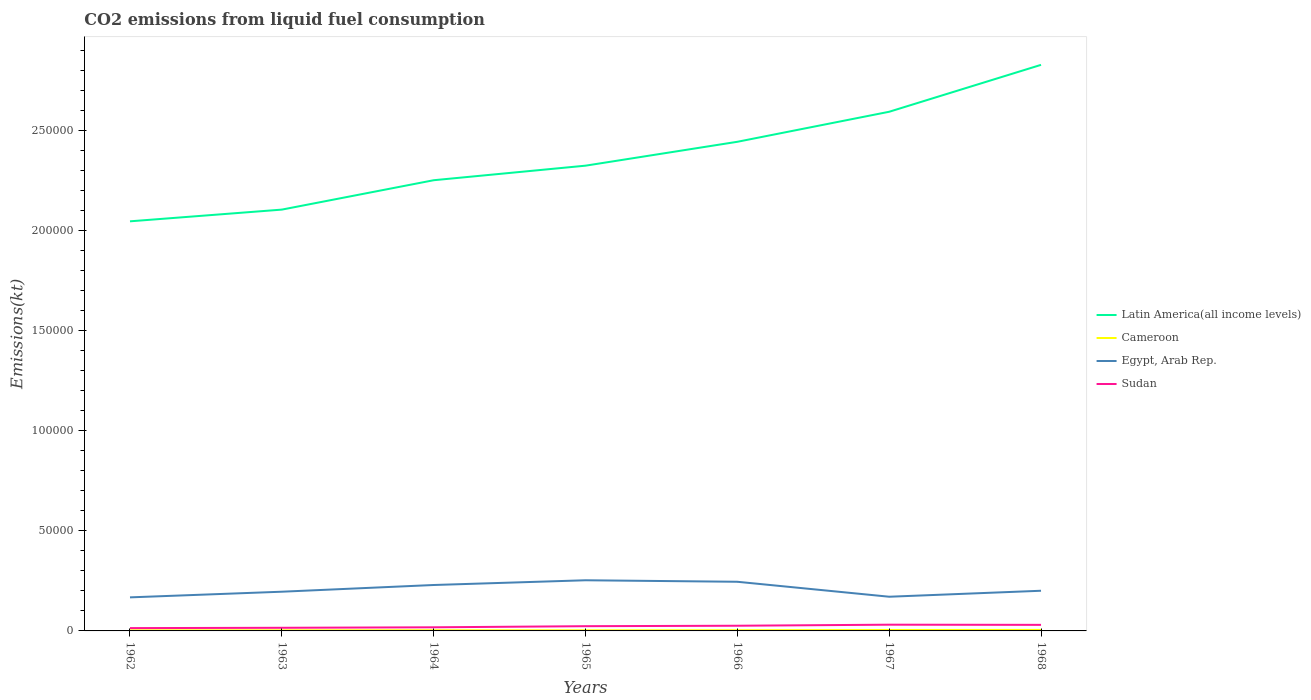How many different coloured lines are there?
Make the answer very short. 4. Is the number of lines equal to the number of legend labels?
Make the answer very short. Yes. Across all years, what is the maximum amount of CO2 emitted in Cameroon?
Provide a succinct answer. 289.69. In which year was the amount of CO2 emitted in Latin America(all income levels) maximum?
Your response must be concise. 1962. What is the total amount of CO2 emitted in Egypt, Arab Rep. in the graph?
Give a very brief answer. 751.74. What is the difference between the highest and the second highest amount of CO2 emitted in Latin America(all income levels)?
Keep it short and to the point. 7.82e+04. Is the amount of CO2 emitted in Egypt, Arab Rep. strictly greater than the amount of CO2 emitted in Cameroon over the years?
Provide a succinct answer. No. How many years are there in the graph?
Make the answer very short. 7. What is the difference between two consecutive major ticks on the Y-axis?
Offer a terse response. 5.00e+04. How many legend labels are there?
Ensure brevity in your answer.  4. What is the title of the graph?
Keep it short and to the point. CO2 emissions from liquid fuel consumption. What is the label or title of the Y-axis?
Your answer should be compact. Emissions(kt). What is the Emissions(kt) of Latin America(all income levels) in 1962?
Your response must be concise. 2.05e+05. What is the Emissions(kt) of Cameroon in 1962?
Give a very brief answer. 289.69. What is the Emissions(kt) of Egypt, Arab Rep. in 1962?
Ensure brevity in your answer.  1.68e+04. What is the Emissions(kt) in Sudan in 1962?
Ensure brevity in your answer.  1408.13. What is the Emissions(kt) in Latin America(all income levels) in 1963?
Make the answer very short. 2.11e+05. What is the Emissions(kt) of Cameroon in 1963?
Provide a succinct answer. 300.69. What is the Emissions(kt) of Egypt, Arab Rep. in 1963?
Ensure brevity in your answer.  1.96e+04. What is the Emissions(kt) of Sudan in 1963?
Keep it short and to the point. 1569.48. What is the Emissions(kt) of Latin America(all income levels) in 1964?
Offer a terse response. 2.25e+05. What is the Emissions(kt) of Cameroon in 1964?
Your answer should be very brief. 337.36. What is the Emissions(kt) of Egypt, Arab Rep. in 1964?
Offer a very short reply. 2.30e+04. What is the Emissions(kt) of Sudan in 1964?
Ensure brevity in your answer.  1815.16. What is the Emissions(kt) of Latin America(all income levels) in 1965?
Keep it short and to the point. 2.33e+05. What is the Emissions(kt) of Cameroon in 1965?
Keep it short and to the point. 311.69. What is the Emissions(kt) of Egypt, Arab Rep. in 1965?
Your response must be concise. 2.53e+04. What is the Emissions(kt) of Sudan in 1965?
Offer a very short reply. 2368.88. What is the Emissions(kt) in Latin America(all income levels) in 1966?
Offer a very short reply. 2.44e+05. What is the Emissions(kt) in Cameroon in 1966?
Give a very brief answer. 344.7. What is the Emissions(kt) of Egypt, Arab Rep. in 1966?
Provide a succinct answer. 2.46e+04. What is the Emissions(kt) in Sudan in 1966?
Make the answer very short. 2592.57. What is the Emissions(kt) in Latin America(all income levels) in 1967?
Offer a terse response. 2.59e+05. What is the Emissions(kt) in Cameroon in 1967?
Provide a succinct answer. 458.38. What is the Emissions(kt) of Egypt, Arab Rep. in 1967?
Offer a very short reply. 1.71e+04. What is the Emissions(kt) of Sudan in 1967?
Offer a terse response. 3116.95. What is the Emissions(kt) in Latin America(all income levels) in 1968?
Ensure brevity in your answer.  2.83e+05. What is the Emissions(kt) in Cameroon in 1968?
Offer a very short reply. 502.38. What is the Emissions(kt) in Egypt, Arab Rep. in 1968?
Provide a short and direct response. 2.01e+04. What is the Emissions(kt) in Sudan in 1968?
Provide a succinct answer. 3028.94. Across all years, what is the maximum Emissions(kt) of Latin America(all income levels)?
Give a very brief answer. 2.83e+05. Across all years, what is the maximum Emissions(kt) in Cameroon?
Make the answer very short. 502.38. Across all years, what is the maximum Emissions(kt) in Egypt, Arab Rep.?
Your response must be concise. 2.53e+04. Across all years, what is the maximum Emissions(kt) in Sudan?
Your answer should be very brief. 3116.95. Across all years, what is the minimum Emissions(kt) in Latin America(all income levels)?
Offer a very short reply. 2.05e+05. Across all years, what is the minimum Emissions(kt) of Cameroon?
Offer a very short reply. 289.69. Across all years, what is the minimum Emissions(kt) of Egypt, Arab Rep.?
Keep it short and to the point. 1.68e+04. Across all years, what is the minimum Emissions(kt) in Sudan?
Your response must be concise. 1408.13. What is the total Emissions(kt) in Latin America(all income levels) in the graph?
Offer a terse response. 1.66e+06. What is the total Emissions(kt) in Cameroon in the graph?
Offer a terse response. 2544.9. What is the total Emissions(kt) in Egypt, Arab Rep. in the graph?
Your response must be concise. 1.46e+05. What is the total Emissions(kt) in Sudan in the graph?
Offer a very short reply. 1.59e+04. What is the difference between the Emissions(kt) in Latin America(all income levels) in 1962 and that in 1963?
Provide a short and direct response. -5855.18. What is the difference between the Emissions(kt) in Cameroon in 1962 and that in 1963?
Make the answer very short. -11. What is the difference between the Emissions(kt) in Egypt, Arab Rep. in 1962 and that in 1963?
Your answer should be compact. -2823.59. What is the difference between the Emissions(kt) in Sudan in 1962 and that in 1963?
Your answer should be very brief. -161.35. What is the difference between the Emissions(kt) in Latin America(all income levels) in 1962 and that in 1964?
Your answer should be very brief. -2.05e+04. What is the difference between the Emissions(kt) in Cameroon in 1962 and that in 1964?
Ensure brevity in your answer.  -47.67. What is the difference between the Emissions(kt) of Egypt, Arab Rep. in 1962 and that in 1964?
Give a very brief answer. -6178.9. What is the difference between the Emissions(kt) of Sudan in 1962 and that in 1964?
Offer a very short reply. -407.04. What is the difference between the Emissions(kt) in Latin America(all income levels) in 1962 and that in 1965?
Your response must be concise. -2.78e+04. What is the difference between the Emissions(kt) of Cameroon in 1962 and that in 1965?
Offer a very short reply. -22. What is the difference between the Emissions(kt) in Egypt, Arab Rep. in 1962 and that in 1965?
Your response must be concise. -8544.11. What is the difference between the Emissions(kt) of Sudan in 1962 and that in 1965?
Offer a very short reply. -960.75. What is the difference between the Emissions(kt) of Latin America(all income levels) in 1962 and that in 1966?
Keep it short and to the point. -3.97e+04. What is the difference between the Emissions(kt) in Cameroon in 1962 and that in 1966?
Your answer should be compact. -55.01. What is the difference between the Emissions(kt) in Egypt, Arab Rep. in 1962 and that in 1966?
Make the answer very short. -7792.38. What is the difference between the Emissions(kt) in Sudan in 1962 and that in 1966?
Your answer should be compact. -1184.44. What is the difference between the Emissions(kt) in Latin America(all income levels) in 1962 and that in 1967?
Provide a short and direct response. -5.48e+04. What is the difference between the Emissions(kt) of Cameroon in 1962 and that in 1967?
Your answer should be compact. -168.68. What is the difference between the Emissions(kt) in Egypt, Arab Rep. in 1962 and that in 1967?
Your response must be concise. -315.36. What is the difference between the Emissions(kt) in Sudan in 1962 and that in 1967?
Your answer should be very brief. -1708.82. What is the difference between the Emissions(kt) of Latin America(all income levels) in 1962 and that in 1968?
Ensure brevity in your answer.  -7.82e+04. What is the difference between the Emissions(kt) in Cameroon in 1962 and that in 1968?
Make the answer very short. -212.69. What is the difference between the Emissions(kt) in Egypt, Arab Rep. in 1962 and that in 1968?
Provide a succinct answer. -3300.3. What is the difference between the Emissions(kt) of Sudan in 1962 and that in 1968?
Give a very brief answer. -1620.81. What is the difference between the Emissions(kt) in Latin America(all income levels) in 1963 and that in 1964?
Your response must be concise. -1.47e+04. What is the difference between the Emissions(kt) of Cameroon in 1963 and that in 1964?
Make the answer very short. -36.67. What is the difference between the Emissions(kt) of Egypt, Arab Rep. in 1963 and that in 1964?
Provide a succinct answer. -3355.3. What is the difference between the Emissions(kt) in Sudan in 1963 and that in 1964?
Give a very brief answer. -245.69. What is the difference between the Emissions(kt) in Latin America(all income levels) in 1963 and that in 1965?
Keep it short and to the point. -2.20e+04. What is the difference between the Emissions(kt) of Cameroon in 1963 and that in 1965?
Make the answer very short. -11. What is the difference between the Emissions(kt) of Egypt, Arab Rep. in 1963 and that in 1965?
Provide a short and direct response. -5720.52. What is the difference between the Emissions(kt) in Sudan in 1963 and that in 1965?
Provide a succinct answer. -799.41. What is the difference between the Emissions(kt) of Latin America(all income levels) in 1963 and that in 1966?
Keep it short and to the point. -3.39e+04. What is the difference between the Emissions(kt) in Cameroon in 1963 and that in 1966?
Make the answer very short. -44. What is the difference between the Emissions(kt) in Egypt, Arab Rep. in 1963 and that in 1966?
Your response must be concise. -4968.78. What is the difference between the Emissions(kt) of Sudan in 1963 and that in 1966?
Your response must be concise. -1023.09. What is the difference between the Emissions(kt) in Latin America(all income levels) in 1963 and that in 1967?
Provide a succinct answer. -4.89e+04. What is the difference between the Emissions(kt) of Cameroon in 1963 and that in 1967?
Your answer should be very brief. -157.68. What is the difference between the Emissions(kt) of Egypt, Arab Rep. in 1963 and that in 1967?
Your answer should be compact. 2508.23. What is the difference between the Emissions(kt) in Sudan in 1963 and that in 1967?
Provide a short and direct response. -1547.47. What is the difference between the Emissions(kt) in Latin America(all income levels) in 1963 and that in 1968?
Offer a very short reply. -7.23e+04. What is the difference between the Emissions(kt) in Cameroon in 1963 and that in 1968?
Give a very brief answer. -201.69. What is the difference between the Emissions(kt) of Egypt, Arab Rep. in 1963 and that in 1968?
Provide a short and direct response. -476.71. What is the difference between the Emissions(kt) in Sudan in 1963 and that in 1968?
Provide a succinct answer. -1459.47. What is the difference between the Emissions(kt) in Latin America(all income levels) in 1964 and that in 1965?
Your answer should be compact. -7274.5. What is the difference between the Emissions(kt) in Cameroon in 1964 and that in 1965?
Give a very brief answer. 25.67. What is the difference between the Emissions(kt) in Egypt, Arab Rep. in 1964 and that in 1965?
Ensure brevity in your answer.  -2365.22. What is the difference between the Emissions(kt) of Sudan in 1964 and that in 1965?
Make the answer very short. -553.72. What is the difference between the Emissions(kt) of Latin America(all income levels) in 1964 and that in 1966?
Offer a terse response. -1.92e+04. What is the difference between the Emissions(kt) in Cameroon in 1964 and that in 1966?
Keep it short and to the point. -7.33. What is the difference between the Emissions(kt) of Egypt, Arab Rep. in 1964 and that in 1966?
Give a very brief answer. -1613.48. What is the difference between the Emissions(kt) of Sudan in 1964 and that in 1966?
Provide a succinct answer. -777.4. What is the difference between the Emissions(kt) in Latin America(all income levels) in 1964 and that in 1967?
Provide a short and direct response. -3.42e+04. What is the difference between the Emissions(kt) in Cameroon in 1964 and that in 1967?
Keep it short and to the point. -121.01. What is the difference between the Emissions(kt) of Egypt, Arab Rep. in 1964 and that in 1967?
Offer a terse response. 5863.53. What is the difference between the Emissions(kt) in Sudan in 1964 and that in 1967?
Provide a short and direct response. -1301.79. What is the difference between the Emissions(kt) of Latin America(all income levels) in 1964 and that in 1968?
Make the answer very short. -5.77e+04. What is the difference between the Emissions(kt) in Cameroon in 1964 and that in 1968?
Your answer should be compact. -165.01. What is the difference between the Emissions(kt) of Egypt, Arab Rep. in 1964 and that in 1968?
Make the answer very short. 2878.59. What is the difference between the Emissions(kt) in Sudan in 1964 and that in 1968?
Provide a short and direct response. -1213.78. What is the difference between the Emissions(kt) in Latin America(all income levels) in 1965 and that in 1966?
Provide a succinct answer. -1.19e+04. What is the difference between the Emissions(kt) in Cameroon in 1965 and that in 1966?
Provide a succinct answer. -33. What is the difference between the Emissions(kt) of Egypt, Arab Rep. in 1965 and that in 1966?
Offer a very short reply. 751.74. What is the difference between the Emissions(kt) of Sudan in 1965 and that in 1966?
Make the answer very short. -223.69. What is the difference between the Emissions(kt) in Latin America(all income levels) in 1965 and that in 1967?
Your answer should be compact. -2.69e+04. What is the difference between the Emissions(kt) in Cameroon in 1965 and that in 1967?
Make the answer very short. -146.68. What is the difference between the Emissions(kt) of Egypt, Arab Rep. in 1965 and that in 1967?
Your answer should be compact. 8228.75. What is the difference between the Emissions(kt) of Sudan in 1965 and that in 1967?
Your response must be concise. -748.07. What is the difference between the Emissions(kt) in Latin America(all income levels) in 1965 and that in 1968?
Make the answer very short. -5.04e+04. What is the difference between the Emissions(kt) in Cameroon in 1965 and that in 1968?
Keep it short and to the point. -190.68. What is the difference between the Emissions(kt) in Egypt, Arab Rep. in 1965 and that in 1968?
Your answer should be compact. 5243.81. What is the difference between the Emissions(kt) of Sudan in 1965 and that in 1968?
Offer a very short reply. -660.06. What is the difference between the Emissions(kt) in Latin America(all income levels) in 1966 and that in 1967?
Your answer should be very brief. -1.50e+04. What is the difference between the Emissions(kt) of Cameroon in 1966 and that in 1967?
Provide a succinct answer. -113.68. What is the difference between the Emissions(kt) of Egypt, Arab Rep. in 1966 and that in 1967?
Offer a very short reply. 7477.01. What is the difference between the Emissions(kt) in Sudan in 1966 and that in 1967?
Offer a very short reply. -524.38. What is the difference between the Emissions(kt) of Latin America(all income levels) in 1966 and that in 1968?
Your answer should be very brief. -3.85e+04. What is the difference between the Emissions(kt) of Cameroon in 1966 and that in 1968?
Make the answer very short. -157.68. What is the difference between the Emissions(kt) of Egypt, Arab Rep. in 1966 and that in 1968?
Offer a terse response. 4492.07. What is the difference between the Emissions(kt) in Sudan in 1966 and that in 1968?
Your answer should be compact. -436.37. What is the difference between the Emissions(kt) in Latin America(all income levels) in 1967 and that in 1968?
Your answer should be very brief. -2.34e+04. What is the difference between the Emissions(kt) of Cameroon in 1967 and that in 1968?
Your response must be concise. -44. What is the difference between the Emissions(kt) in Egypt, Arab Rep. in 1967 and that in 1968?
Make the answer very short. -2984.94. What is the difference between the Emissions(kt) of Sudan in 1967 and that in 1968?
Offer a terse response. 88.01. What is the difference between the Emissions(kt) in Latin America(all income levels) in 1962 and the Emissions(kt) in Cameroon in 1963?
Give a very brief answer. 2.04e+05. What is the difference between the Emissions(kt) of Latin America(all income levels) in 1962 and the Emissions(kt) of Egypt, Arab Rep. in 1963?
Give a very brief answer. 1.85e+05. What is the difference between the Emissions(kt) of Latin America(all income levels) in 1962 and the Emissions(kt) of Sudan in 1963?
Ensure brevity in your answer.  2.03e+05. What is the difference between the Emissions(kt) in Cameroon in 1962 and the Emissions(kt) in Egypt, Arab Rep. in 1963?
Your answer should be very brief. -1.93e+04. What is the difference between the Emissions(kt) of Cameroon in 1962 and the Emissions(kt) of Sudan in 1963?
Your response must be concise. -1279.78. What is the difference between the Emissions(kt) in Egypt, Arab Rep. in 1962 and the Emissions(kt) in Sudan in 1963?
Offer a terse response. 1.52e+04. What is the difference between the Emissions(kt) in Latin America(all income levels) in 1962 and the Emissions(kt) in Cameroon in 1964?
Keep it short and to the point. 2.04e+05. What is the difference between the Emissions(kt) in Latin America(all income levels) in 1962 and the Emissions(kt) in Egypt, Arab Rep. in 1964?
Ensure brevity in your answer.  1.82e+05. What is the difference between the Emissions(kt) in Latin America(all income levels) in 1962 and the Emissions(kt) in Sudan in 1964?
Your answer should be compact. 2.03e+05. What is the difference between the Emissions(kt) in Cameroon in 1962 and the Emissions(kt) in Egypt, Arab Rep. in 1964?
Provide a short and direct response. -2.27e+04. What is the difference between the Emissions(kt) in Cameroon in 1962 and the Emissions(kt) in Sudan in 1964?
Your response must be concise. -1525.47. What is the difference between the Emissions(kt) in Egypt, Arab Rep. in 1962 and the Emissions(kt) in Sudan in 1964?
Your answer should be compact. 1.50e+04. What is the difference between the Emissions(kt) in Latin America(all income levels) in 1962 and the Emissions(kt) in Cameroon in 1965?
Your answer should be compact. 2.04e+05. What is the difference between the Emissions(kt) of Latin America(all income levels) in 1962 and the Emissions(kt) of Egypt, Arab Rep. in 1965?
Give a very brief answer. 1.79e+05. What is the difference between the Emissions(kt) of Latin America(all income levels) in 1962 and the Emissions(kt) of Sudan in 1965?
Your answer should be compact. 2.02e+05. What is the difference between the Emissions(kt) of Cameroon in 1962 and the Emissions(kt) of Egypt, Arab Rep. in 1965?
Make the answer very short. -2.50e+04. What is the difference between the Emissions(kt) in Cameroon in 1962 and the Emissions(kt) in Sudan in 1965?
Provide a succinct answer. -2079.19. What is the difference between the Emissions(kt) of Egypt, Arab Rep. in 1962 and the Emissions(kt) of Sudan in 1965?
Your answer should be compact. 1.44e+04. What is the difference between the Emissions(kt) of Latin America(all income levels) in 1962 and the Emissions(kt) of Cameroon in 1966?
Give a very brief answer. 2.04e+05. What is the difference between the Emissions(kt) in Latin America(all income levels) in 1962 and the Emissions(kt) in Egypt, Arab Rep. in 1966?
Keep it short and to the point. 1.80e+05. What is the difference between the Emissions(kt) in Latin America(all income levels) in 1962 and the Emissions(kt) in Sudan in 1966?
Your answer should be very brief. 2.02e+05. What is the difference between the Emissions(kt) of Cameroon in 1962 and the Emissions(kt) of Egypt, Arab Rep. in 1966?
Ensure brevity in your answer.  -2.43e+04. What is the difference between the Emissions(kt) in Cameroon in 1962 and the Emissions(kt) in Sudan in 1966?
Your answer should be very brief. -2302.88. What is the difference between the Emissions(kt) of Egypt, Arab Rep. in 1962 and the Emissions(kt) of Sudan in 1966?
Ensure brevity in your answer.  1.42e+04. What is the difference between the Emissions(kt) in Latin America(all income levels) in 1962 and the Emissions(kt) in Cameroon in 1967?
Give a very brief answer. 2.04e+05. What is the difference between the Emissions(kt) of Latin America(all income levels) in 1962 and the Emissions(kt) of Egypt, Arab Rep. in 1967?
Provide a succinct answer. 1.88e+05. What is the difference between the Emissions(kt) of Latin America(all income levels) in 1962 and the Emissions(kt) of Sudan in 1967?
Give a very brief answer. 2.02e+05. What is the difference between the Emissions(kt) of Cameroon in 1962 and the Emissions(kt) of Egypt, Arab Rep. in 1967?
Provide a succinct answer. -1.68e+04. What is the difference between the Emissions(kt) of Cameroon in 1962 and the Emissions(kt) of Sudan in 1967?
Offer a terse response. -2827.26. What is the difference between the Emissions(kt) in Egypt, Arab Rep. in 1962 and the Emissions(kt) in Sudan in 1967?
Your answer should be very brief. 1.37e+04. What is the difference between the Emissions(kt) in Latin America(all income levels) in 1962 and the Emissions(kt) in Cameroon in 1968?
Your response must be concise. 2.04e+05. What is the difference between the Emissions(kt) in Latin America(all income levels) in 1962 and the Emissions(kt) in Egypt, Arab Rep. in 1968?
Provide a succinct answer. 1.85e+05. What is the difference between the Emissions(kt) in Latin America(all income levels) in 1962 and the Emissions(kt) in Sudan in 1968?
Give a very brief answer. 2.02e+05. What is the difference between the Emissions(kt) in Cameroon in 1962 and the Emissions(kt) in Egypt, Arab Rep. in 1968?
Your answer should be very brief. -1.98e+04. What is the difference between the Emissions(kt) of Cameroon in 1962 and the Emissions(kt) of Sudan in 1968?
Keep it short and to the point. -2739.25. What is the difference between the Emissions(kt) in Egypt, Arab Rep. in 1962 and the Emissions(kt) in Sudan in 1968?
Make the answer very short. 1.37e+04. What is the difference between the Emissions(kt) in Latin America(all income levels) in 1963 and the Emissions(kt) in Cameroon in 1964?
Your answer should be compact. 2.10e+05. What is the difference between the Emissions(kt) of Latin America(all income levels) in 1963 and the Emissions(kt) of Egypt, Arab Rep. in 1964?
Provide a short and direct response. 1.88e+05. What is the difference between the Emissions(kt) of Latin America(all income levels) in 1963 and the Emissions(kt) of Sudan in 1964?
Your response must be concise. 2.09e+05. What is the difference between the Emissions(kt) of Cameroon in 1963 and the Emissions(kt) of Egypt, Arab Rep. in 1964?
Give a very brief answer. -2.27e+04. What is the difference between the Emissions(kt) of Cameroon in 1963 and the Emissions(kt) of Sudan in 1964?
Give a very brief answer. -1514.47. What is the difference between the Emissions(kt) in Egypt, Arab Rep. in 1963 and the Emissions(kt) in Sudan in 1964?
Ensure brevity in your answer.  1.78e+04. What is the difference between the Emissions(kt) in Latin America(all income levels) in 1963 and the Emissions(kt) in Cameroon in 1965?
Provide a succinct answer. 2.10e+05. What is the difference between the Emissions(kt) of Latin America(all income levels) in 1963 and the Emissions(kt) of Egypt, Arab Rep. in 1965?
Your response must be concise. 1.85e+05. What is the difference between the Emissions(kt) in Latin America(all income levels) in 1963 and the Emissions(kt) in Sudan in 1965?
Provide a short and direct response. 2.08e+05. What is the difference between the Emissions(kt) of Cameroon in 1963 and the Emissions(kt) of Egypt, Arab Rep. in 1965?
Your response must be concise. -2.50e+04. What is the difference between the Emissions(kt) in Cameroon in 1963 and the Emissions(kt) in Sudan in 1965?
Provide a short and direct response. -2068.19. What is the difference between the Emissions(kt) in Egypt, Arab Rep. in 1963 and the Emissions(kt) in Sudan in 1965?
Ensure brevity in your answer.  1.72e+04. What is the difference between the Emissions(kt) of Latin America(all income levels) in 1963 and the Emissions(kt) of Cameroon in 1966?
Offer a very short reply. 2.10e+05. What is the difference between the Emissions(kt) of Latin America(all income levels) in 1963 and the Emissions(kt) of Egypt, Arab Rep. in 1966?
Your response must be concise. 1.86e+05. What is the difference between the Emissions(kt) in Latin America(all income levels) in 1963 and the Emissions(kt) in Sudan in 1966?
Your answer should be compact. 2.08e+05. What is the difference between the Emissions(kt) of Cameroon in 1963 and the Emissions(kt) of Egypt, Arab Rep. in 1966?
Offer a very short reply. -2.43e+04. What is the difference between the Emissions(kt) of Cameroon in 1963 and the Emissions(kt) of Sudan in 1966?
Your answer should be compact. -2291.88. What is the difference between the Emissions(kt) in Egypt, Arab Rep. in 1963 and the Emissions(kt) in Sudan in 1966?
Keep it short and to the point. 1.70e+04. What is the difference between the Emissions(kt) in Latin America(all income levels) in 1963 and the Emissions(kt) in Cameroon in 1967?
Your answer should be compact. 2.10e+05. What is the difference between the Emissions(kt) of Latin America(all income levels) in 1963 and the Emissions(kt) of Egypt, Arab Rep. in 1967?
Offer a very short reply. 1.93e+05. What is the difference between the Emissions(kt) of Latin America(all income levels) in 1963 and the Emissions(kt) of Sudan in 1967?
Your response must be concise. 2.07e+05. What is the difference between the Emissions(kt) of Cameroon in 1963 and the Emissions(kt) of Egypt, Arab Rep. in 1967?
Your response must be concise. -1.68e+04. What is the difference between the Emissions(kt) in Cameroon in 1963 and the Emissions(kt) in Sudan in 1967?
Offer a very short reply. -2816.26. What is the difference between the Emissions(kt) of Egypt, Arab Rep. in 1963 and the Emissions(kt) of Sudan in 1967?
Keep it short and to the point. 1.65e+04. What is the difference between the Emissions(kt) in Latin America(all income levels) in 1963 and the Emissions(kt) in Cameroon in 1968?
Your response must be concise. 2.10e+05. What is the difference between the Emissions(kt) in Latin America(all income levels) in 1963 and the Emissions(kt) in Egypt, Arab Rep. in 1968?
Your answer should be very brief. 1.90e+05. What is the difference between the Emissions(kt) in Latin America(all income levels) in 1963 and the Emissions(kt) in Sudan in 1968?
Your answer should be very brief. 2.08e+05. What is the difference between the Emissions(kt) in Cameroon in 1963 and the Emissions(kt) in Egypt, Arab Rep. in 1968?
Offer a very short reply. -1.98e+04. What is the difference between the Emissions(kt) of Cameroon in 1963 and the Emissions(kt) of Sudan in 1968?
Provide a succinct answer. -2728.25. What is the difference between the Emissions(kt) of Egypt, Arab Rep. in 1963 and the Emissions(kt) of Sudan in 1968?
Offer a very short reply. 1.66e+04. What is the difference between the Emissions(kt) in Latin America(all income levels) in 1964 and the Emissions(kt) in Cameroon in 1965?
Your answer should be very brief. 2.25e+05. What is the difference between the Emissions(kt) in Latin America(all income levels) in 1964 and the Emissions(kt) in Egypt, Arab Rep. in 1965?
Your answer should be compact. 2.00e+05. What is the difference between the Emissions(kt) in Latin America(all income levels) in 1964 and the Emissions(kt) in Sudan in 1965?
Make the answer very short. 2.23e+05. What is the difference between the Emissions(kt) in Cameroon in 1964 and the Emissions(kt) in Egypt, Arab Rep. in 1965?
Your response must be concise. -2.50e+04. What is the difference between the Emissions(kt) in Cameroon in 1964 and the Emissions(kt) in Sudan in 1965?
Provide a succinct answer. -2031.52. What is the difference between the Emissions(kt) in Egypt, Arab Rep. in 1964 and the Emissions(kt) in Sudan in 1965?
Offer a terse response. 2.06e+04. What is the difference between the Emissions(kt) in Latin America(all income levels) in 1964 and the Emissions(kt) in Cameroon in 1966?
Provide a short and direct response. 2.25e+05. What is the difference between the Emissions(kt) of Latin America(all income levels) in 1964 and the Emissions(kt) of Egypt, Arab Rep. in 1966?
Make the answer very short. 2.01e+05. What is the difference between the Emissions(kt) in Latin America(all income levels) in 1964 and the Emissions(kt) in Sudan in 1966?
Provide a short and direct response. 2.23e+05. What is the difference between the Emissions(kt) of Cameroon in 1964 and the Emissions(kt) of Egypt, Arab Rep. in 1966?
Provide a short and direct response. -2.42e+04. What is the difference between the Emissions(kt) in Cameroon in 1964 and the Emissions(kt) in Sudan in 1966?
Make the answer very short. -2255.2. What is the difference between the Emissions(kt) of Egypt, Arab Rep. in 1964 and the Emissions(kt) of Sudan in 1966?
Offer a terse response. 2.04e+04. What is the difference between the Emissions(kt) of Latin America(all income levels) in 1964 and the Emissions(kt) of Cameroon in 1967?
Provide a succinct answer. 2.25e+05. What is the difference between the Emissions(kt) of Latin America(all income levels) in 1964 and the Emissions(kt) of Egypt, Arab Rep. in 1967?
Make the answer very short. 2.08e+05. What is the difference between the Emissions(kt) in Latin America(all income levels) in 1964 and the Emissions(kt) in Sudan in 1967?
Your answer should be compact. 2.22e+05. What is the difference between the Emissions(kt) in Cameroon in 1964 and the Emissions(kt) in Egypt, Arab Rep. in 1967?
Give a very brief answer. -1.68e+04. What is the difference between the Emissions(kt) in Cameroon in 1964 and the Emissions(kt) in Sudan in 1967?
Keep it short and to the point. -2779.59. What is the difference between the Emissions(kt) of Egypt, Arab Rep. in 1964 and the Emissions(kt) of Sudan in 1967?
Your response must be concise. 1.98e+04. What is the difference between the Emissions(kt) of Latin America(all income levels) in 1964 and the Emissions(kt) of Cameroon in 1968?
Offer a very short reply. 2.25e+05. What is the difference between the Emissions(kt) in Latin America(all income levels) in 1964 and the Emissions(kt) in Egypt, Arab Rep. in 1968?
Your answer should be very brief. 2.05e+05. What is the difference between the Emissions(kt) of Latin America(all income levels) in 1964 and the Emissions(kt) of Sudan in 1968?
Give a very brief answer. 2.22e+05. What is the difference between the Emissions(kt) of Cameroon in 1964 and the Emissions(kt) of Egypt, Arab Rep. in 1968?
Offer a terse response. -1.97e+04. What is the difference between the Emissions(kt) in Cameroon in 1964 and the Emissions(kt) in Sudan in 1968?
Make the answer very short. -2691.58. What is the difference between the Emissions(kt) of Egypt, Arab Rep. in 1964 and the Emissions(kt) of Sudan in 1968?
Your answer should be compact. 1.99e+04. What is the difference between the Emissions(kt) of Latin America(all income levels) in 1965 and the Emissions(kt) of Cameroon in 1966?
Your answer should be compact. 2.32e+05. What is the difference between the Emissions(kt) in Latin America(all income levels) in 1965 and the Emissions(kt) in Egypt, Arab Rep. in 1966?
Provide a succinct answer. 2.08e+05. What is the difference between the Emissions(kt) in Latin America(all income levels) in 1965 and the Emissions(kt) in Sudan in 1966?
Provide a succinct answer. 2.30e+05. What is the difference between the Emissions(kt) in Cameroon in 1965 and the Emissions(kt) in Egypt, Arab Rep. in 1966?
Your response must be concise. -2.43e+04. What is the difference between the Emissions(kt) of Cameroon in 1965 and the Emissions(kt) of Sudan in 1966?
Offer a terse response. -2280.87. What is the difference between the Emissions(kt) in Egypt, Arab Rep. in 1965 and the Emissions(kt) in Sudan in 1966?
Offer a terse response. 2.27e+04. What is the difference between the Emissions(kt) of Latin America(all income levels) in 1965 and the Emissions(kt) of Cameroon in 1967?
Your answer should be very brief. 2.32e+05. What is the difference between the Emissions(kt) in Latin America(all income levels) in 1965 and the Emissions(kt) in Egypt, Arab Rep. in 1967?
Keep it short and to the point. 2.15e+05. What is the difference between the Emissions(kt) in Latin America(all income levels) in 1965 and the Emissions(kt) in Sudan in 1967?
Give a very brief answer. 2.29e+05. What is the difference between the Emissions(kt) in Cameroon in 1965 and the Emissions(kt) in Egypt, Arab Rep. in 1967?
Give a very brief answer. -1.68e+04. What is the difference between the Emissions(kt) in Cameroon in 1965 and the Emissions(kt) in Sudan in 1967?
Offer a terse response. -2805.26. What is the difference between the Emissions(kt) in Egypt, Arab Rep. in 1965 and the Emissions(kt) in Sudan in 1967?
Your answer should be compact. 2.22e+04. What is the difference between the Emissions(kt) of Latin America(all income levels) in 1965 and the Emissions(kt) of Cameroon in 1968?
Give a very brief answer. 2.32e+05. What is the difference between the Emissions(kt) of Latin America(all income levels) in 1965 and the Emissions(kt) of Egypt, Arab Rep. in 1968?
Offer a very short reply. 2.12e+05. What is the difference between the Emissions(kt) in Latin America(all income levels) in 1965 and the Emissions(kt) in Sudan in 1968?
Offer a terse response. 2.29e+05. What is the difference between the Emissions(kt) of Cameroon in 1965 and the Emissions(kt) of Egypt, Arab Rep. in 1968?
Your answer should be very brief. -1.98e+04. What is the difference between the Emissions(kt) of Cameroon in 1965 and the Emissions(kt) of Sudan in 1968?
Ensure brevity in your answer.  -2717.25. What is the difference between the Emissions(kt) in Egypt, Arab Rep. in 1965 and the Emissions(kt) in Sudan in 1968?
Provide a short and direct response. 2.23e+04. What is the difference between the Emissions(kt) of Latin America(all income levels) in 1966 and the Emissions(kt) of Cameroon in 1967?
Keep it short and to the point. 2.44e+05. What is the difference between the Emissions(kt) of Latin America(all income levels) in 1966 and the Emissions(kt) of Egypt, Arab Rep. in 1967?
Your answer should be compact. 2.27e+05. What is the difference between the Emissions(kt) in Latin America(all income levels) in 1966 and the Emissions(kt) in Sudan in 1967?
Give a very brief answer. 2.41e+05. What is the difference between the Emissions(kt) of Cameroon in 1966 and the Emissions(kt) of Egypt, Arab Rep. in 1967?
Offer a very short reply. -1.67e+04. What is the difference between the Emissions(kt) of Cameroon in 1966 and the Emissions(kt) of Sudan in 1967?
Offer a very short reply. -2772.25. What is the difference between the Emissions(kt) of Egypt, Arab Rep. in 1966 and the Emissions(kt) of Sudan in 1967?
Give a very brief answer. 2.14e+04. What is the difference between the Emissions(kt) of Latin America(all income levels) in 1966 and the Emissions(kt) of Cameroon in 1968?
Give a very brief answer. 2.44e+05. What is the difference between the Emissions(kt) of Latin America(all income levels) in 1966 and the Emissions(kt) of Egypt, Arab Rep. in 1968?
Give a very brief answer. 2.24e+05. What is the difference between the Emissions(kt) in Latin America(all income levels) in 1966 and the Emissions(kt) in Sudan in 1968?
Offer a very short reply. 2.41e+05. What is the difference between the Emissions(kt) in Cameroon in 1966 and the Emissions(kt) in Egypt, Arab Rep. in 1968?
Ensure brevity in your answer.  -1.97e+04. What is the difference between the Emissions(kt) in Cameroon in 1966 and the Emissions(kt) in Sudan in 1968?
Offer a very short reply. -2684.24. What is the difference between the Emissions(kt) of Egypt, Arab Rep. in 1966 and the Emissions(kt) of Sudan in 1968?
Ensure brevity in your answer.  2.15e+04. What is the difference between the Emissions(kt) of Latin America(all income levels) in 1967 and the Emissions(kt) of Cameroon in 1968?
Provide a succinct answer. 2.59e+05. What is the difference between the Emissions(kt) in Latin America(all income levels) in 1967 and the Emissions(kt) in Egypt, Arab Rep. in 1968?
Make the answer very short. 2.39e+05. What is the difference between the Emissions(kt) in Latin America(all income levels) in 1967 and the Emissions(kt) in Sudan in 1968?
Provide a succinct answer. 2.56e+05. What is the difference between the Emissions(kt) in Cameroon in 1967 and the Emissions(kt) in Egypt, Arab Rep. in 1968?
Ensure brevity in your answer.  -1.96e+04. What is the difference between the Emissions(kt) in Cameroon in 1967 and the Emissions(kt) in Sudan in 1968?
Your answer should be very brief. -2570.57. What is the difference between the Emissions(kt) of Egypt, Arab Rep. in 1967 and the Emissions(kt) of Sudan in 1968?
Your response must be concise. 1.41e+04. What is the average Emissions(kt) of Latin America(all income levels) per year?
Offer a very short reply. 2.37e+05. What is the average Emissions(kt) in Cameroon per year?
Offer a very short reply. 363.56. What is the average Emissions(kt) in Egypt, Arab Rep. per year?
Provide a short and direct response. 2.09e+04. What is the average Emissions(kt) in Sudan per year?
Provide a succinct answer. 2271.44. In the year 1962, what is the difference between the Emissions(kt) in Latin America(all income levels) and Emissions(kt) in Cameroon?
Give a very brief answer. 2.04e+05. In the year 1962, what is the difference between the Emissions(kt) of Latin America(all income levels) and Emissions(kt) of Egypt, Arab Rep.?
Give a very brief answer. 1.88e+05. In the year 1962, what is the difference between the Emissions(kt) in Latin America(all income levels) and Emissions(kt) in Sudan?
Ensure brevity in your answer.  2.03e+05. In the year 1962, what is the difference between the Emissions(kt) in Cameroon and Emissions(kt) in Egypt, Arab Rep.?
Provide a succinct answer. -1.65e+04. In the year 1962, what is the difference between the Emissions(kt) in Cameroon and Emissions(kt) in Sudan?
Your response must be concise. -1118.43. In the year 1962, what is the difference between the Emissions(kt) of Egypt, Arab Rep. and Emissions(kt) of Sudan?
Ensure brevity in your answer.  1.54e+04. In the year 1963, what is the difference between the Emissions(kt) of Latin America(all income levels) and Emissions(kt) of Cameroon?
Keep it short and to the point. 2.10e+05. In the year 1963, what is the difference between the Emissions(kt) in Latin America(all income levels) and Emissions(kt) in Egypt, Arab Rep.?
Provide a short and direct response. 1.91e+05. In the year 1963, what is the difference between the Emissions(kt) of Latin America(all income levels) and Emissions(kt) of Sudan?
Give a very brief answer. 2.09e+05. In the year 1963, what is the difference between the Emissions(kt) in Cameroon and Emissions(kt) in Egypt, Arab Rep.?
Ensure brevity in your answer.  -1.93e+04. In the year 1963, what is the difference between the Emissions(kt) of Cameroon and Emissions(kt) of Sudan?
Offer a terse response. -1268.78. In the year 1963, what is the difference between the Emissions(kt) in Egypt, Arab Rep. and Emissions(kt) in Sudan?
Provide a succinct answer. 1.80e+04. In the year 1964, what is the difference between the Emissions(kt) of Latin America(all income levels) and Emissions(kt) of Cameroon?
Offer a very short reply. 2.25e+05. In the year 1964, what is the difference between the Emissions(kt) in Latin America(all income levels) and Emissions(kt) in Egypt, Arab Rep.?
Your answer should be compact. 2.02e+05. In the year 1964, what is the difference between the Emissions(kt) of Latin America(all income levels) and Emissions(kt) of Sudan?
Offer a very short reply. 2.23e+05. In the year 1964, what is the difference between the Emissions(kt) in Cameroon and Emissions(kt) in Egypt, Arab Rep.?
Give a very brief answer. -2.26e+04. In the year 1964, what is the difference between the Emissions(kt) in Cameroon and Emissions(kt) in Sudan?
Your answer should be very brief. -1477.8. In the year 1964, what is the difference between the Emissions(kt) of Egypt, Arab Rep. and Emissions(kt) of Sudan?
Make the answer very short. 2.11e+04. In the year 1965, what is the difference between the Emissions(kt) of Latin America(all income levels) and Emissions(kt) of Cameroon?
Provide a short and direct response. 2.32e+05. In the year 1965, what is the difference between the Emissions(kt) of Latin America(all income levels) and Emissions(kt) of Egypt, Arab Rep.?
Keep it short and to the point. 2.07e+05. In the year 1965, what is the difference between the Emissions(kt) of Latin America(all income levels) and Emissions(kt) of Sudan?
Your answer should be very brief. 2.30e+05. In the year 1965, what is the difference between the Emissions(kt) of Cameroon and Emissions(kt) of Egypt, Arab Rep.?
Your answer should be compact. -2.50e+04. In the year 1965, what is the difference between the Emissions(kt) in Cameroon and Emissions(kt) in Sudan?
Provide a succinct answer. -2057.19. In the year 1965, what is the difference between the Emissions(kt) of Egypt, Arab Rep. and Emissions(kt) of Sudan?
Your response must be concise. 2.29e+04. In the year 1966, what is the difference between the Emissions(kt) of Latin America(all income levels) and Emissions(kt) of Cameroon?
Your response must be concise. 2.44e+05. In the year 1966, what is the difference between the Emissions(kt) of Latin America(all income levels) and Emissions(kt) of Egypt, Arab Rep.?
Give a very brief answer. 2.20e+05. In the year 1966, what is the difference between the Emissions(kt) of Latin America(all income levels) and Emissions(kt) of Sudan?
Provide a short and direct response. 2.42e+05. In the year 1966, what is the difference between the Emissions(kt) of Cameroon and Emissions(kt) of Egypt, Arab Rep.?
Give a very brief answer. -2.42e+04. In the year 1966, what is the difference between the Emissions(kt) of Cameroon and Emissions(kt) of Sudan?
Offer a terse response. -2247.87. In the year 1966, what is the difference between the Emissions(kt) of Egypt, Arab Rep. and Emissions(kt) of Sudan?
Ensure brevity in your answer.  2.20e+04. In the year 1967, what is the difference between the Emissions(kt) of Latin America(all income levels) and Emissions(kt) of Cameroon?
Provide a succinct answer. 2.59e+05. In the year 1967, what is the difference between the Emissions(kt) in Latin America(all income levels) and Emissions(kt) in Egypt, Arab Rep.?
Make the answer very short. 2.42e+05. In the year 1967, what is the difference between the Emissions(kt) of Latin America(all income levels) and Emissions(kt) of Sudan?
Your answer should be compact. 2.56e+05. In the year 1967, what is the difference between the Emissions(kt) of Cameroon and Emissions(kt) of Egypt, Arab Rep.?
Provide a succinct answer. -1.66e+04. In the year 1967, what is the difference between the Emissions(kt) of Cameroon and Emissions(kt) of Sudan?
Give a very brief answer. -2658.57. In the year 1967, what is the difference between the Emissions(kt) of Egypt, Arab Rep. and Emissions(kt) of Sudan?
Provide a short and direct response. 1.40e+04. In the year 1968, what is the difference between the Emissions(kt) of Latin America(all income levels) and Emissions(kt) of Cameroon?
Give a very brief answer. 2.82e+05. In the year 1968, what is the difference between the Emissions(kt) of Latin America(all income levels) and Emissions(kt) of Egypt, Arab Rep.?
Your answer should be compact. 2.63e+05. In the year 1968, what is the difference between the Emissions(kt) in Latin America(all income levels) and Emissions(kt) in Sudan?
Ensure brevity in your answer.  2.80e+05. In the year 1968, what is the difference between the Emissions(kt) in Cameroon and Emissions(kt) in Egypt, Arab Rep.?
Ensure brevity in your answer.  -1.96e+04. In the year 1968, what is the difference between the Emissions(kt) in Cameroon and Emissions(kt) in Sudan?
Your answer should be very brief. -2526.56. In the year 1968, what is the difference between the Emissions(kt) in Egypt, Arab Rep. and Emissions(kt) in Sudan?
Provide a short and direct response. 1.70e+04. What is the ratio of the Emissions(kt) in Latin America(all income levels) in 1962 to that in 1963?
Your response must be concise. 0.97. What is the ratio of the Emissions(kt) of Cameroon in 1962 to that in 1963?
Your answer should be compact. 0.96. What is the ratio of the Emissions(kt) of Egypt, Arab Rep. in 1962 to that in 1963?
Your answer should be very brief. 0.86. What is the ratio of the Emissions(kt) in Sudan in 1962 to that in 1963?
Your answer should be compact. 0.9. What is the ratio of the Emissions(kt) of Latin America(all income levels) in 1962 to that in 1964?
Keep it short and to the point. 0.91. What is the ratio of the Emissions(kt) of Cameroon in 1962 to that in 1964?
Your answer should be very brief. 0.86. What is the ratio of the Emissions(kt) of Egypt, Arab Rep. in 1962 to that in 1964?
Your answer should be very brief. 0.73. What is the ratio of the Emissions(kt) of Sudan in 1962 to that in 1964?
Provide a succinct answer. 0.78. What is the ratio of the Emissions(kt) in Latin America(all income levels) in 1962 to that in 1965?
Your answer should be compact. 0.88. What is the ratio of the Emissions(kt) of Cameroon in 1962 to that in 1965?
Ensure brevity in your answer.  0.93. What is the ratio of the Emissions(kt) of Egypt, Arab Rep. in 1962 to that in 1965?
Provide a short and direct response. 0.66. What is the ratio of the Emissions(kt) in Sudan in 1962 to that in 1965?
Your answer should be compact. 0.59. What is the ratio of the Emissions(kt) of Latin America(all income levels) in 1962 to that in 1966?
Your answer should be compact. 0.84. What is the ratio of the Emissions(kt) in Cameroon in 1962 to that in 1966?
Your answer should be compact. 0.84. What is the ratio of the Emissions(kt) of Egypt, Arab Rep. in 1962 to that in 1966?
Your answer should be very brief. 0.68. What is the ratio of the Emissions(kt) of Sudan in 1962 to that in 1966?
Your answer should be compact. 0.54. What is the ratio of the Emissions(kt) in Latin America(all income levels) in 1962 to that in 1967?
Make the answer very short. 0.79. What is the ratio of the Emissions(kt) in Cameroon in 1962 to that in 1967?
Keep it short and to the point. 0.63. What is the ratio of the Emissions(kt) of Egypt, Arab Rep. in 1962 to that in 1967?
Provide a succinct answer. 0.98. What is the ratio of the Emissions(kt) of Sudan in 1962 to that in 1967?
Make the answer very short. 0.45. What is the ratio of the Emissions(kt) of Latin America(all income levels) in 1962 to that in 1968?
Your response must be concise. 0.72. What is the ratio of the Emissions(kt) in Cameroon in 1962 to that in 1968?
Your answer should be compact. 0.58. What is the ratio of the Emissions(kt) in Egypt, Arab Rep. in 1962 to that in 1968?
Give a very brief answer. 0.84. What is the ratio of the Emissions(kt) in Sudan in 1962 to that in 1968?
Your response must be concise. 0.46. What is the ratio of the Emissions(kt) of Latin America(all income levels) in 1963 to that in 1964?
Your answer should be very brief. 0.93. What is the ratio of the Emissions(kt) in Cameroon in 1963 to that in 1964?
Your answer should be compact. 0.89. What is the ratio of the Emissions(kt) of Egypt, Arab Rep. in 1963 to that in 1964?
Ensure brevity in your answer.  0.85. What is the ratio of the Emissions(kt) of Sudan in 1963 to that in 1964?
Your answer should be very brief. 0.86. What is the ratio of the Emissions(kt) in Latin America(all income levels) in 1963 to that in 1965?
Give a very brief answer. 0.91. What is the ratio of the Emissions(kt) in Cameroon in 1963 to that in 1965?
Ensure brevity in your answer.  0.96. What is the ratio of the Emissions(kt) in Egypt, Arab Rep. in 1963 to that in 1965?
Provide a short and direct response. 0.77. What is the ratio of the Emissions(kt) in Sudan in 1963 to that in 1965?
Make the answer very short. 0.66. What is the ratio of the Emissions(kt) of Latin America(all income levels) in 1963 to that in 1966?
Your response must be concise. 0.86. What is the ratio of the Emissions(kt) of Cameroon in 1963 to that in 1966?
Offer a terse response. 0.87. What is the ratio of the Emissions(kt) in Egypt, Arab Rep. in 1963 to that in 1966?
Offer a very short reply. 0.8. What is the ratio of the Emissions(kt) in Sudan in 1963 to that in 1966?
Your response must be concise. 0.61. What is the ratio of the Emissions(kt) of Latin America(all income levels) in 1963 to that in 1967?
Make the answer very short. 0.81. What is the ratio of the Emissions(kt) of Cameroon in 1963 to that in 1967?
Offer a terse response. 0.66. What is the ratio of the Emissions(kt) of Egypt, Arab Rep. in 1963 to that in 1967?
Provide a short and direct response. 1.15. What is the ratio of the Emissions(kt) in Sudan in 1963 to that in 1967?
Your response must be concise. 0.5. What is the ratio of the Emissions(kt) in Latin America(all income levels) in 1963 to that in 1968?
Your answer should be compact. 0.74. What is the ratio of the Emissions(kt) of Cameroon in 1963 to that in 1968?
Keep it short and to the point. 0.6. What is the ratio of the Emissions(kt) of Egypt, Arab Rep. in 1963 to that in 1968?
Your answer should be very brief. 0.98. What is the ratio of the Emissions(kt) in Sudan in 1963 to that in 1968?
Offer a very short reply. 0.52. What is the ratio of the Emissions(kt) in Latin America(all income levels) in 1964 to that in 1965?
Your response must be concise. 0.97. What is the ratio of the Emissions(kt) in Cameroon in 1964 to that in 1965?
Ensure brevity in your answer.  1.08. What is the ratio of the Emissions(kt) of Egypt, Arab Rep. in 1964 to that in 1965?
Ensure brevity in your answer.  0.91. What is the ratio of the Emissions(kt) in Sudan in 1964 to that in 1965?
Keep it short and to the point. 0.77. What is the ratio of the Emissions(kt) in Latin America(all income levels) in 1964 to that in 1966?
Provide a short and direct response. 0.92. What is the ratio of the Emissions(kt) of Cameroon in 1964 to that in 1966?
Offer a terse response. 0.98. What is the ratio of the Emissions(kt) in Egypt, Arab Rep. in 1964 to that in 1966?
Make the answer very short. 0.93. What is the ratio of the Emissions(kt) of Sudan in 1964 to that in 1966?
Provide a succinct answer. 0.7. What is the ratio of the Emissions(kt) of Latin America(all income levels) in 1964 to that in 1967?
Ensure brevity in your answer.  0.87. What is the ratio of the Emissions(kt) of Cameroon in 1964 to that in 1967?
Your response must be concise. 0.74. What is the ratio of the Emissions(kt) of Egypt, Arab Rep. in 1964 to that in 1967?
Offer a terse response. 1.34. What is the ratio of the Emissions(kt) in Sudan in 1964 to that in 1967?
Provide a succinct answer. 0.58. What is the ratio of the Emissions(kt) of Latin America(all income levels) in 1964 to that in 1968?
Offer a terse response. 0.8. What is the ratio of the Emissions(kt) of Cameroon in 1964 to that in 1968?
Your answer should be compact. 0.67. What is the ratio of the Emissions(kt) of Egypt, Arab Rep. in 1964 to that in 1968?
Make the answer very short. 1.14. What is the ratio of the Emissions(kt) of Sudan in 1964 to that in 1968?
Your answer should be very brief. 0.6. What is the ratio of the Emissions(kt) of Latin America(all income levels) in 1965 to that in 1966?
Your answer should be compact. 0.95. What is the ratio of the Emissions(kt) in Cameroon in 1965 to that in 1966?
Provide a short and direct response. 0.9. What is the ratio of the Emissions(kt) of Egypt, Arab Rep. in 1965 to that in 1966?
Your response must be concise. 1.03. What is the ratio of the Emissions(kt) in Sudan in 1965 to that in 1966?
Keep it short and to the point. 0.91. What is the ratio of the Emissions(kt) in Latin America(all income levels) in 1965 to that in 1967?
Offer a very short reply. 0.9. What is the ratio of the Emissions(kt) in Cameroon in 1965 to that in 1967?
Offer a terse response. 0.68. What is the ratio of the Emissions(kt) of Egypt, Arab Rep. in 1965 to that in 1967?
Offer a terse response. 1.48. What is the ratio of the Emissions(kt) of Sudan in 1965 to that in 1967?
Offer a terse response. 0.76. What is the ratio of the Emissions(kt) of Latin America(all income levels) in 1965 to that in 1968?
Give a very brief answer. 0.82. What is the ratio of the Emissions(kt) of Cameroon in 1965 to that in 1968?
Ensure brevity in your answer.  0.62. What is the ratio of the Emissions(kt) in Egypt, Arab Rep. in 1965 to that in 1968?
Your answer should be compact. 1.26. What is the ratio of the Emissions(kt) in Sudan in 1965 to that in 1968?
Provide a succinct answer. 0.78. What is the ratio of the Emissions(kt) in Latin America(all income levels) in 1966 to that in 1967?
Offer a terse response. 0.94. What is the ratio of the Emissions(kt) in Cameroon in 1966 to that in 1967?
Your answer should be very brief. 0.75. What is the ratio of the Emissions(kt) of Egypt, Arab Rep. in 1966 to that in 1967?
Offer a terse response. 1.44. What is the ratio of the Emissions(kt) of Sudan in 1966 to that in 1967?
Offer a very short reply. 0.83. What is the ratio of the Emissions(kt) in Latin America(all income levels) in 1966 to that in 1968?
Keep it short and to the point. 0.86. What is the ratio of the Emissions(kt) of Cameroon in 1966 to that in 1968?
Provide a succinct answer. 0.69. What is the ratio of the Emissions(kt) in Egypt, Arab Rep. in 1966 to that in 1968?
Your answer should be very brief. 1.22. What is the ratio of the Emissions(kt) of Sudan in 1966 to that in 1968?
Make the answer very short. 0.86. What is the ratio of the Emissions(kt) in Latin America(all income levels) in 1967 to that in 1968?
Keep it short and to the point. 0.92. What is the ratio of the Emissions(kt) in Cameroon in 1967 to that in 1968?
Make the answer very short. 0.91. What is the ratio of the Emissions(kt) in Egypt, Arab Rep. in 1967 to that in 1968?
Provide a short and direct response. 0.85. What is the ratio of the Emissions(kt) of Sudan in 1967 to that in 1968?
Your response must be concise. 1.03. What is the difference between the highest and the second highest Emissions(kt) in Latin America(all income levels)?
Keep it short and to the point. 2.34e+04. What is the difference between the highest and the second highest Emissions(kt) in Cameroon?
Ensure brevity in your answer.  44. What is the difference between the highest and the second highest Emissions(kt) in Egypt, Arab Rep.?
Ensure brevity in your answer.  751.74. What is the difference between the highest and the second highest Emissions(kt) in Sudan?
Keep it short and to the point. 88.01. What is the difference between the highest and the lowest Emissions(kt) in Latin America(all income levels)?
Offer a terse response. 7.82e+04. What is the difference between the highest and the lowest Emissions(kt) of Cameroon?
Provide a succinct answer. 212.69. What is the difference between the highest and the lowest Emissions(kt) in Egypt, Arab Rep.?
Provide a short and direct response. 8544.11. What is the difference between the highest and the lowest Emissions(kt) of Sudan?
Provide a short and direct response. 1708.82. 